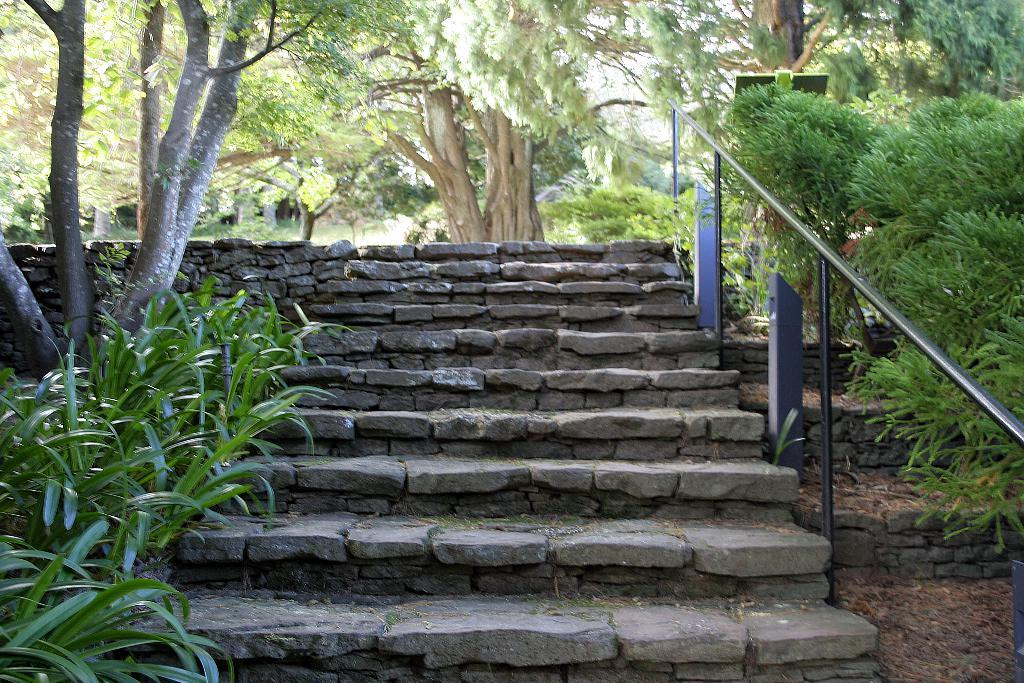What type of structure is present in the image? There is a staircase in the image. What other objects can be seen in the image? There are poles and a group of plants visible in the image. What is placed on one of the poles? There is a board placed on a pole in the image. What can be seen in the distance at the top of the image? There is a group of trees visible at the top of the image. What type of bell can be heard ringing in the image? There is no bell present in the image, and therefore no sound can be heard. 